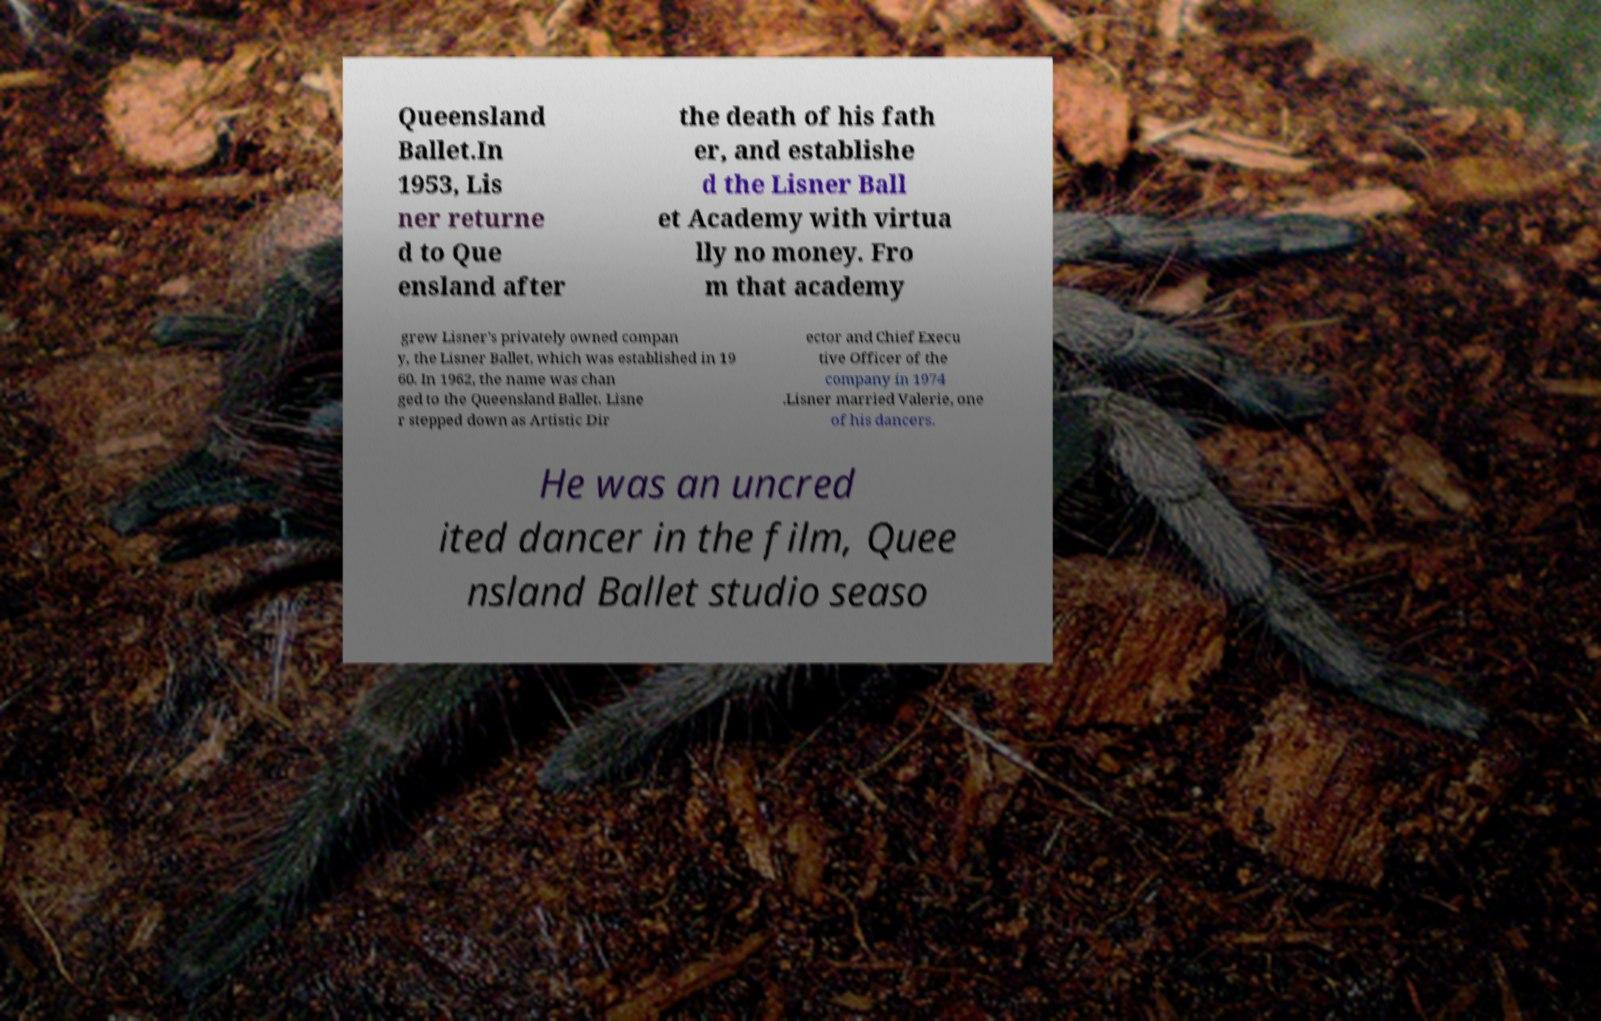Can you accurately transcribe the text from the provided image for me? Queensland Ballet.In 1953, Lis ner returne d to Que ensland after the death of his fath er, and establishe d the Lisner Ball et Academy with virtua lly no money. Fro m that academy grew Lisner's privately owned compan y, the Lisner Ballet, which was established in 19 60. In 1962, the name was chan ged to the Queensland Ballet. Lisne r stepped down as Artistic Dir ector and Chief Execu tive Officer of the company in 1974 .Lisner married Valerie, one of his dancers. He was an uncred ited dancer in the film, Quee nsland Ballet studio seaso 